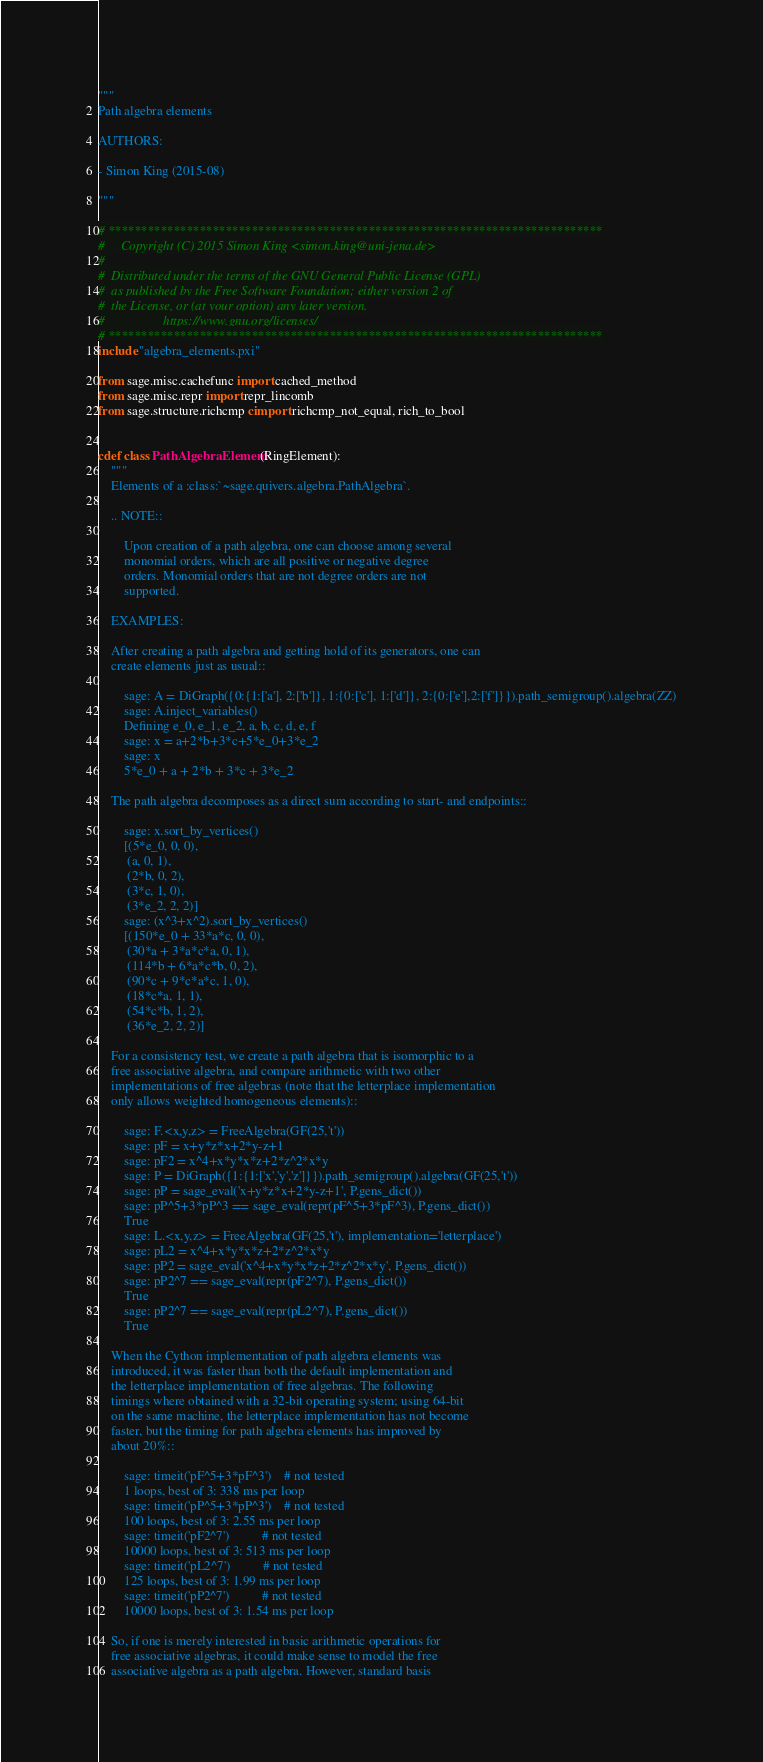Convert code to text. <code><loc_0><loc_0><loc_500><loc_500><_Cython_>"""
Path algebra elements

AUTHORS:

- Simon King (2015-08)

"""

# ****************************************************************************
#     Copyright (C) 2015 Simon King <simon.king@uni-jena.de>
#
#  Distributed under the terms of the GNU General Public License (GPL)
#  as published by the Free Software Foundation; either version 2 of
#  the License, or (at your option) any later version.
#                  https://www.gnu.org/licenses/
# ****************************************************************************
include "algebra_elements.pxi"

from sage.misc.cachefunc import cached_method
from sage.misc.repr import repr_lincomb
from sage.structure.richcmp cimport richcmp_not_equal, rich_to_bool


cdef class PathAlgebraElement(RingElement):
    """
    Elements of a :class:`~sage.quivers.algebra.PathAlgebra`.

    .. NOTE::

        Upon creation of a path algebra, one can choose among several
        monomial orders, which are all positive or negative degree
        orders. Monomial orders that are not degree orders are not
        supported.

    EXAMPLES:

    After creating a path algebra and getting hold of its generators, one can
    create elements just as usual::

        sage: A = DiGraph({0:{1:['a'], 2:['b']}, 1:{0:['c'], 1:['d']}, 2:{0:['e'],2:['f']}}).path_semigroup().algebra(ZZ)
        sage: A.inject_variables()
        Defining e_0, e_1, e_2, a, b, c, d, e, f
        sage: x = a+2*b+3*c+5*e_0+3*e_2
        sage: x
        5*e_0 + a + 2*b + 3*c + 3*e_2

    The path algebra decomposes as a direct sum according to start- and endpoints::

        sage: x.sort_by_vertices()
        [(5*e_0, 0, 0),
         (a, 0, 1),
         (2*b, 0, 2),
         (3*c, 1, 0),
         (3*e_2, 2, 2)]
        sage: (x^3+x^2).sort_by_vertices()
        [(150*e_0 + 33*a*c, 0, 0),
         (30*a + 3*a*c*a, 0, 1),
         (114*b + 6*a*c*b, 0, 2),
         (90*c + 9*c*a*c, 1, 0),
         (18*c*a, 1, 1),
         (54*c*b, 1, 2),
         (36*e_2, 2, 2)]

    For a consistency test, we create a path algebra that is isomorphic to a
    free associative algebra, and compare arithmetic with two other
    implementations of free algebras (note that the letterplace implementation
    only allows weighted homogeneous elements)::

        sage: F.<x,y,z> = FreeAlgebra(GF(25,'t'))
        sage: pF = x+y*z*x+2*y-z+1
        sage: pF2 = x^4+x*y*x*z+2*z^2*x*y
        sage: P = DiGraph({1:{1:['x','y','z']}}).path_semigroup().algebra(GF(25,'t'))
        sage: pP = sage_eval('x+y*z*x+2*y-z+1', P.gens_dict())
        sage: pP^5+3*pP^3 == sage_eval(repr(pF^5+3*pF^3), P.gens_dict())
        True
        sage: L.<x,y,z> = FreeAlgebra(GF(25,'t'), implementation='letterplace')
        sage: pL2 = x^4+x*y*x*z+2*z^2*x*y
        sage: pP2 = sage_eval('x^4+x*y*x*z+2*z^2*x*y', P.gens_dict())
        sage: pP2^7 == sage_eval(repr(pF2^7), P.gens_dict())
        True
        sage: pP2^7 == sage_eval(repr(pL2^7), P.gens_dict())
        True

    When the Cython implementation of path algebra elements was
    introduced, it was faster than both the default implementation and
    the letterplace implementation of free algebras. The following
    timings where obtained with a 32-bit operating system; using 64-bit
    on the same machine, the letterplace implementation has not become
    faster, but the timing for path algebra elements has improved by
    about 20%::

        sage: timeit('pF^5+3*pF^3')    # not tested
        1 loops, best of 3: 338 ms per loop
        sage: timeit('pP^5+3*pP^3')    # not tested
        100 loops, best of 3: 2.55 ms per loop
        sage: timeit('pF2^7')          # not tested
        10000 loops, best of 3: 513 ms per loop
        sage: timeit('pL2^7')          # not tested
        125 loops, best of 3: 1.99 ms per loop
        sage: timeit('pP2^7')          # not tested
        10000 loops, best of 3: 1.54 ms per loop

    So, if one is merely interested in basic arithmetic operations for
    free associative algebras, it could make sense to model the free
    associative algebra as a path algebra. However, standard basis</code> 